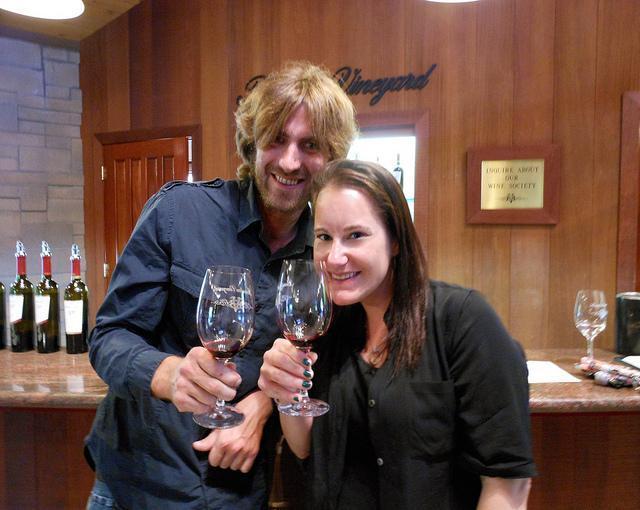How many bottles can be seen?
Give a very brief answer. 3. How many people can you see?
Give a very brief answer. 2. How many wine glasses are in the photo?
Give a very brief answer. 2. 